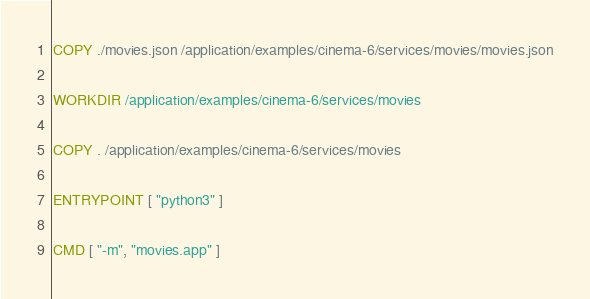Convert code to text. <code><loc_0><loc_0><loc_500><loc_500><_Dockerfile_>COPY ./movies.json /application/examples/cinema-6/services/movies/movies.json

WORKDIR /application/examples/cinema-6/services/movies

COPY . /application/examples/cinema-6/services/movies

ENTRYPOINT [ "python3" ]

CMD [ "-m", "movies.app" ] </code> 